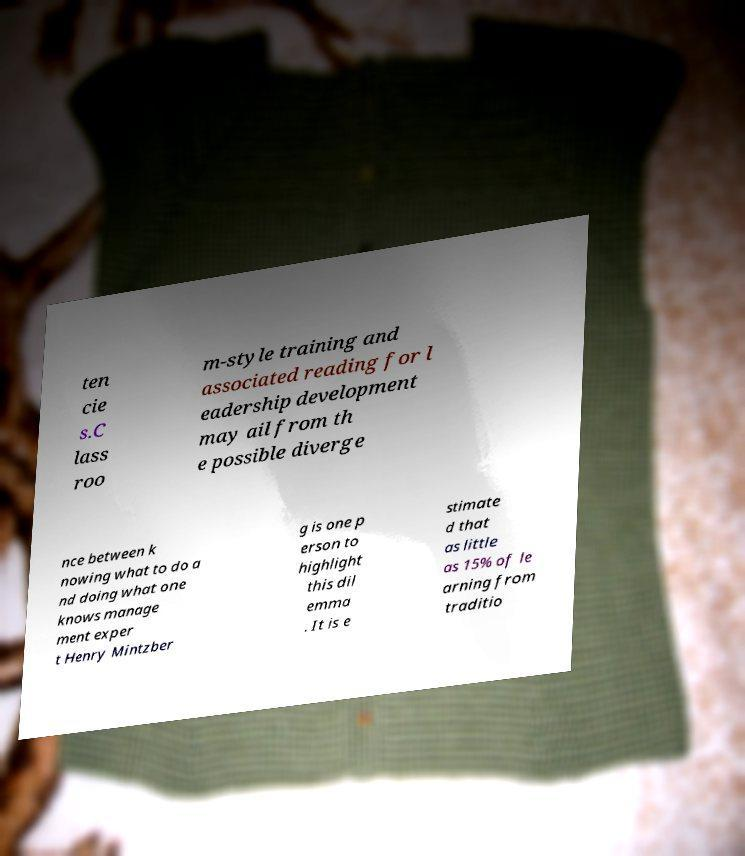Can you read and provide the text displayed in the image?This photo seems to have some interesting text. Can you extract and type it out for me? ten cie s.C lass roo m-style training and associated reading for l eadership development may ail from th e possible diverge nce between k nowing what to do a nd doing what one knows manage ment exper t Henry Mintzber g is one p erson to highlight this dil emma . It is e stimate d that as little as 15% of le arning from traditio 